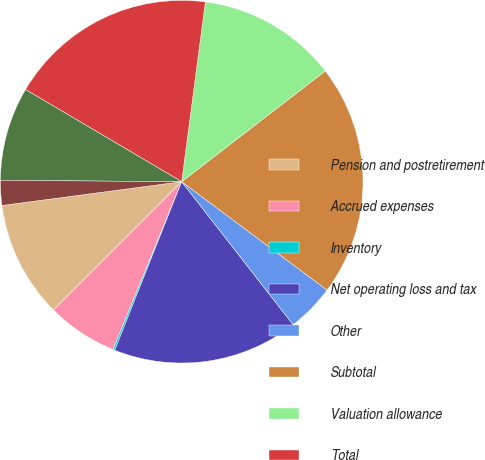Convert chart to OTSL. <chart><loc_0><loc_0><loc_500><loc_500><pie_chart><fcel>Pension and postretirement<fcel>Accrued expenses<fcel>Inventory<fcel>Net operating loss and tax<fcel>Other<fcel>Subtotal<fcel>Valuation allowance<fcel>Total<fcel>Depreciation and amortization<fcel>Investments<nl><fcel>10.41%<fcel>6.31%<fcel>0.17%<fcel>16.55%<fcel>4.27%<fcel>20.65%<fcel>12.46%<fcel>18.6%<fcel>8.36%<fcel>2.22%<nl></chart> 